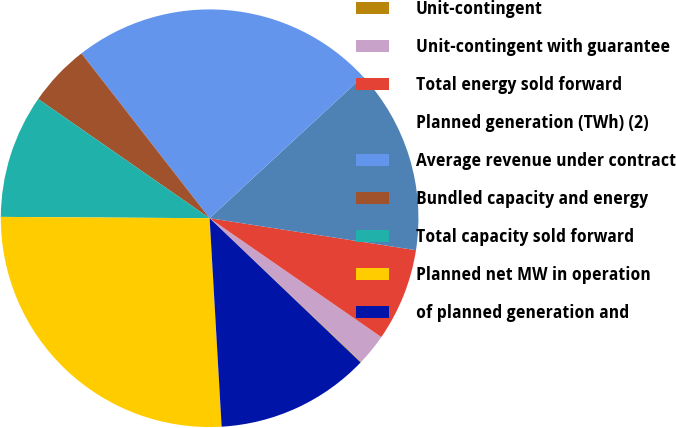<chart> <loc_0><loc_0><loc_500><loc_500><pie_chart><fcel>Unit-contingent<fcel>Unit-contingent with guarantee<fcel>Total energy sold forward<fcel>Planned generation (TWh) (2)<fcel>Average revenue under contract<fcel>Bundled capacity and energy<fcel>Total capacity sold forward<fcel>Planned net MW in operation<fcel>of planned generation and<nl><fcel>0.06%<fcel>2.44%<fcel>7.19%<fcel>14.33%<fcel>23.64%<fcel>4.81%<fcel>9.57%<fcel>26.02%<fcel>11.95%<nl></chart> 